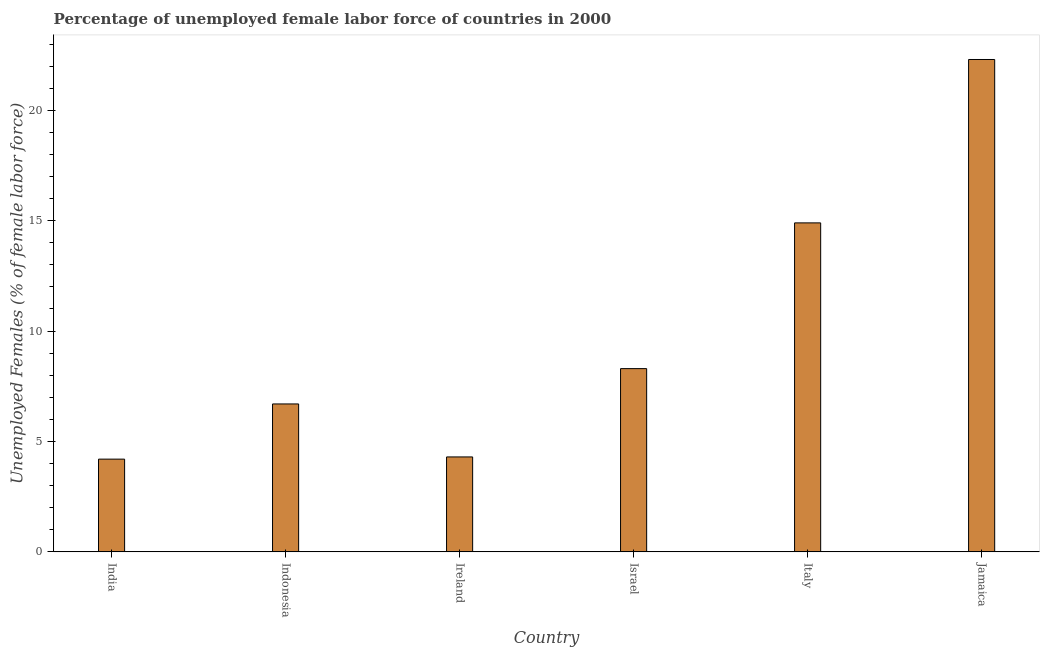Does the graph contain any zero values?
Give a very brief answer. No. Does the graph contain grids?
Give a very brief answer. No. What is the title of the graph?
Make the answer very short. Percentage of unemployed female labor force of countries in 2000. What is the label or title of the Y-axis?
Keep it short and to the point. Unemployed Females (% of female labor force). What is the total unemployed female labour force in Israel?
Your response must be concise. 8.3. Across all countries, what is the maximum total unemployed female labour force?
Ensure brevity in your answer.  22.3. Across all countries, what is the minimum total unemployed female labour force?
Your response must be concise. 4.2. In which country was the total unemployed female labour force maximum?
Your answer should be very brief. Jamaica. In which country was the total unemployed female labour force minimum?
Provide a succinct answer. India. What is the sum of the total unemployed female labour force?
Provide a succinct answer. 60.7. What is the average total unemployed female labour force per country?
Make the answer very short. 10.12. In how many countries, is the total unemployed female labour force greater than 22 %?
Offer a terse response. 1. What is the ratio of the total unemployed female labour force in Ireland to that in Italy?
Give a very brief answer. 0.29. Is the total unemployed female labour force in Indonesia less than that in Italy?
Provide a succinct answer. Yes. What is the difference between the highest and the lowest total unemployed female labour force?
Offer a terse response. 18.1. In how many countries, is the total unemployed female labour force greater than the average total unemployed female labour force taken over all countries?
Offer a very short reply. 2. How many bars are there?
Offer a terse response. 6. Are all the bars in the graph horizontal?
Make the answer very short. No. How many countries are there in the graph?
Provide a short and direct response. 6. Are the values on the major ticks of Y-axis written in scientific E-notation?
Your response must be concise. No. What is the Unemployed Females (% of female labor force) in India?
Ensure brevity in your answer.  4.2. What is the Unemployed Females (% of female labor force) in Indonesia?
Ensure brevity in your answer.  6.7. What is the Unemployed Females (% of female labor force) of Ireland?
Your answer should be very brief. 4.3. What is the Unemployed Females (% of female labor force) of Israel?
Your answer should be very brief. 8.3. What is the Unemployed Females (% of female labor force) in Italy?
Your response must be concise. 14.9. What is the Unemployed Females (% of female labor force) of Jamaica?
Ensure brevity in your answer.  22.3. What is the difference between the Unemployed Females (% of female labor force) in India and Jamaica?
Ensure brevity in your answer.  -18.1. What is the difference between the Unemployed Females (% of female labor force) in Indonesia and Italy?
Provide a succinct answer. -8.2. What is the difference between the Unemployed Females (% of female labor force) in Indonesia and Jamaica?
Your answer should be compact. -15.6. What is the difference between the Unemployed Females (% of female labor force) in Ireland and Italy?
Provide a short and direct response. -10.6. What is the difference between the Unemployed Females (% of female labor force) in Israel and Italy?
Provide a short and direct response. -6.6. What is the difference between the Unemployed Females (% of female labor force) in Israel and Jamaica?
Offer a very short reply. -14. What is the ratio of the Unemployed Females (% of female labor force) in India to that in Indonesia?
Provide a short and direct response. 0.63. What is the ratio of the Unemployed Females (% of female labor force) in India to that in Israel?
Offer a terse response. 0.51. What is the ratio of the Unemployed Females (% of female labor force) in India to that in Italy?
Give a very brief answer. 0.28. What is the ratio of the Unemployed Females (% of female labor force) in India to that in Jamaica?
Keep it short and to the point. 0.19. What is the ratio of the Unemployed Females (% of female labor force) in Indonesia to that in Ireland?
Offer a terse response. 1.56. What is the ratio of the Unemployed Females (% of female labor force) in Indonesia to that in Israel?
Offer a terse response. 0.81. What is the ratio of the Unemployed Females (% of female labor force) in Indonesia to that in Italy?
Your response must be concise. 0.45. What is the ratio of the Unemployed Females (% of female labor force) in Ireland to that in Israel?
Keep it short and to the point. 0.52. What is the ratio of the Unemployed Females (% of female labor force) in Ireland to that in Italy?
Give a very brief answer. 0.29. What is the ratio of the Unemployed Females (% of female labor force) in Ireland to that in Jamaica?
Give a very brief answer. 0.19. What is the ratio of the Unemployed Females (% of female labor force) in Israel to that in Italy?
Give a very brief answer. 0.56. What is the ratio of the Unemployed Females (% of female labor force) in Israel to that in Jamaica?
Provide a succinct answer. 0.37. What is the ratio of the Unemployed Females (% of female labor force) in Italy to that in Jamaica?
Ensure brevity in your answer.  0.67. 